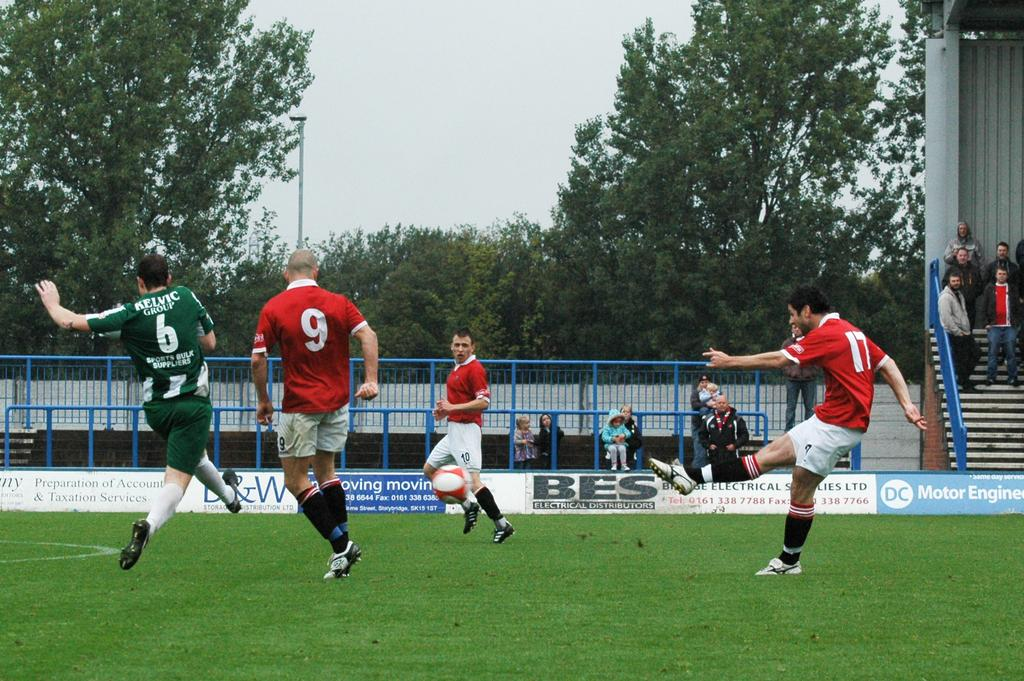<image>
Describe the image concisely. Number 17 has just kicked the soccer ball. 